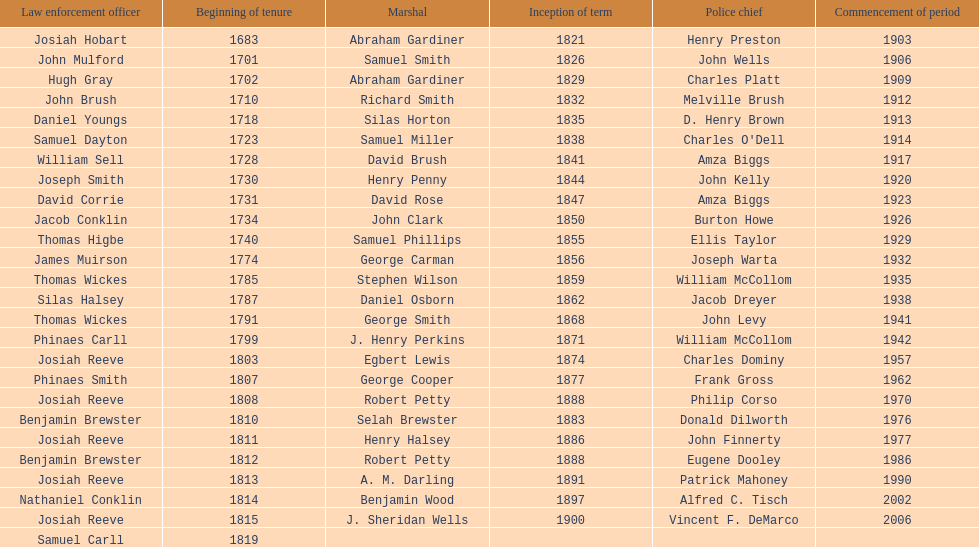Did robert petty serve before josiah reeve? No. 